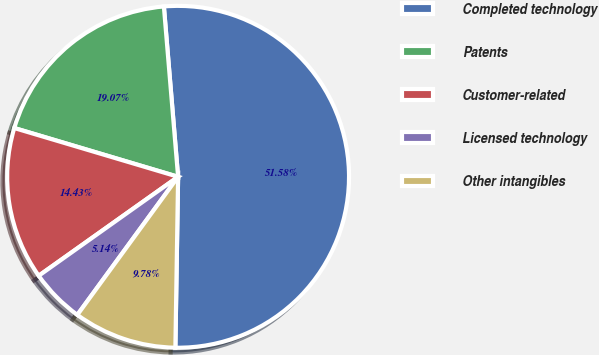Convert chart to OTSL. <chart><loc_0><loc_0><loc_500><loc_500><pie_chart><fcel>Completed technology<fcel>Patents<fcel>Customer-related<fcel>Licensed technology<fcel>Other intangibles<nl><fcel>51.58%<fcel>19.07%<fcel>14.43%<fcel>5.14%<fcel>9.78%<nl></chart> 